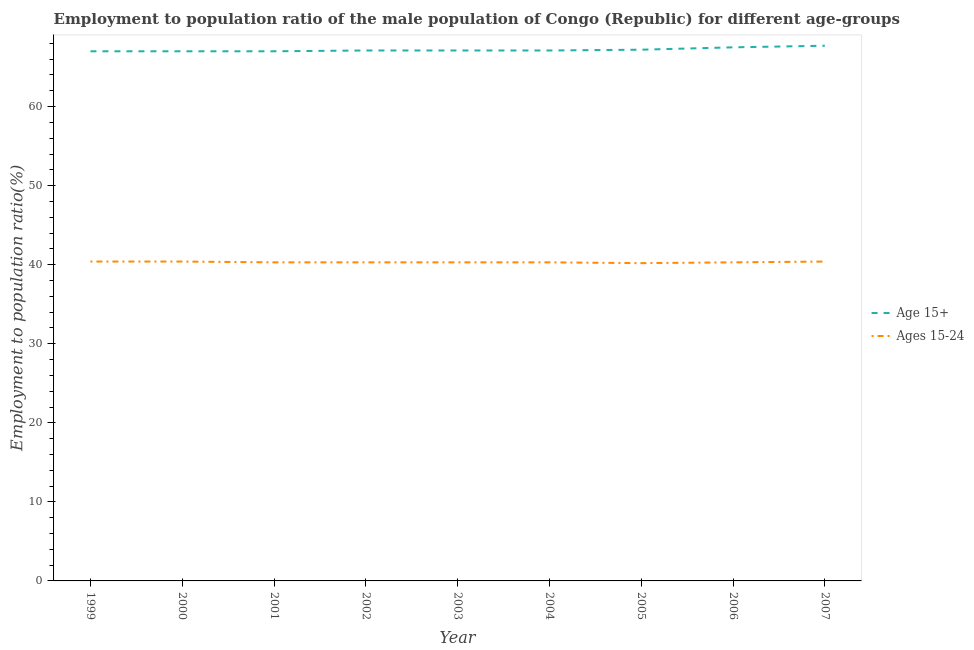How many different coloured lines are there?
Keep it short and to the point. 2. Is the number of lines equal to the number of legend labels?
Give a very brief answer. Yes. What is the employment to population ratio(age 15+) in 2004?
Give a very brief answer. 67.1. Across all years, what is the maximum employment to population ratio(age 15+)?
Offer a very short reply. 67.7. Across all years, what is the minimum employment to population ratio(age 15+)?
Your answer should be compact. 67. What is the total employment to population ratio(age 15+) in the graph?
Your answer should be very brief. 604.7. What is the difference between the employment to population ratio(age 15+) in 1999 and that in 2007?
Ensure brevity in your answer.  -0.7. What is the difference between the employment to population ratio(age 15-24) in 2001 and the employment to population ratio(age 15+) in 2007?
Make the answer very short. -27.4. What is the average employment to population ratio(age 15-24) per year?
Offer a terse response. 40.32. In the year 2004, what is the difference between the employment to population ratio(age 15+) and employment to population ratio(age 15-24)?
Ensure brevity in your answer.  26.8. What is the ratio of the employment to population ratio(age 15-24) in 2001 to that in 2005?
Your answer should be compact. 1. What is the difference between the highest and the lowest employment to population ratio(age 15-24)?
Provide a succinct answer. 0.2. In how many years, is the employment to population ratio(age 15+) greater than the average employment to population ratio(age 15+) taken over all years?
Give a very brief answer. 3. Are the values on the major ticks of Y-axis written in scientific E-notation?
Your answer should be very brief. No. Does the graph contain grids?
Provide a short and direct response. No. Where does the legend appear in the graph?
Offer a very short reply. Center right. How many legend labels are there?
Offer a very short reply. 2. What is the title of the graph?
Your response must be concise. Employment to population ratio of the male population of Congo (Republic) for different age-groups. Does "Personal remittances" appear as one of the legend labels in the graph?
Offer a terse response. No. What is the label or title of the Y-axis?
Ensure brevity in your answer.  Employment to population ratio(%). What is the Employment to population ratio(%) of Ages 15-24 in 1999?
Provide a succinct answer. 40.4. What is the Employment to population ratio(%) in Ages 15-24 in 2000?
Your answer should be very brief. 40.4. What is the Employment to population ratio(%) in Age 15+ in 2001?
Keep it short and to the point. 67. What is the Employment to population ratio(%) of Ages 15-24 in 2001?
Your answer should be very brief. 40.3. What is the Employment to population ratio(%) of Age 15+ in 2002?
Keep it short and to the point. 67.1. What is the Employment to population ratio(%) of Ages 15-24 in 2002?
Provide a short and direct response. 40.3. What is the Employment to population ratio(%) of Age 15+ in 2003?
Your answer should be compact. 67.1. What is the Employment to population ratio(%) of Ages 15-24 in 2003?
Ensure brevity in your answer.  40.3. What is the Employment to population ratio(%) in Age 15+ in 2004?
Offer a terse response. 67.1. What is the Employment to population ratio(%) in Ages 15-24 in 2004?
Offer a very short reply. 40.3. What is the Employment to population ratio(%) in Age 15+ in 2005?
Provide a short and direct response. 67.2. What is the Employment to population ratio(%) of Ages 15-24 in 2005?
Give a very brief answer. 40.2. What is the Employment to population ratio(%) of Age 15+ in 2006?
Offer a terse response. 67.5. What is the Employment to population ratio(%) in Ages 15-24 in 2006?
Keep it short and to the point. 40.3. What is the Employment to population ratio(%) of Age 15+ in 2007?
Your answer should be very brief. 67.7. What is the Employment to population ratio(%) of Ages 15-24 in 2007?
Ensure brevity in your answer.  40.4. Across all years, what is the maximum Employment to population ratio(%) in Age 15+?
Keep it short and to the point. 67.7. Across all years, what is the maximum Employment to population ratio(%) in Ages 15-24?
Give a very brief answer. 40.4. Across all years, what is the minimum Employment to population ratio(%) in Ages 15-24?
Your answer should be compact. 40.2. What is the total Employment to population ratio(%) of Age 15+ in the graph?
Give a very brief answer. 604.7. What is the total Employment to population ratio(%) of Ages 15-24 in the graph?
Ensure brevity in your answer.  362.9. What is the difference between the Employment to population ratio(%) of Age 15+ in 1999 and that in 2000?
Offer a very short reply. 0. What is the difference between the Employment to population ratio(%) in Ages 15-24 in 1999 and that in 2001?
Make the answer very short. 0.1. What is the difference between the Employment to population ratio(%) of Age 15+ in 1999 and that in 2003?
Keep it short and to the point. -0.1. What is the difference between the Employment to population ratio(%) in Age 15+ in 1999 and that in 2004?
Your answer should be very brief. -0.1. What is the difference between the Employment to population ratio(%) in Ages 15-24 in 1999 and that in 2004?
Provide a succinct answer. 0.1. What is the difference between the Employment to population ratio(%) of Age 15+ in 1999 and that in 2005?
Your answer should be compact. -0.2. What is the difference between the Employment to population ratio(%) in Age 15+ in 1999 and that in 2007?
Offer a very short reply. -0.7. What is the difference between the Employment to population ratio(%) in Age 15+ in 2000 and that in 2002?
Ensure brevity in your answer.  -0.1. What is the difference between the Employment to population ratio(%) of Ages 15-24 in 2000 and that in 2002?
Make the answer very short. 0.1. What is the difference between the Employment to population ratio(%) of Age 15+ in 2000 and that in 2003?
Give a very brief answer. -0.1. What is the difference between the Employment to population ratio(%) of Ages 15-24 in 2000 and that in 2003?
Ensure brevity in your answer.  0.1. What is the difference between the Employment to population ratio(%) in Ages 15-24 in 2000 and that in 2004?
Offer a terse response. 0.1. What is the difference between the Employment to population ratio(%) in Age 15+ in 2000 and that in 2006?
Offer a very short reply. -0.5. What is the difference between the Employment to population ratio(%) in Ages 15-24 in 2001 and that in 2002?
Offer a terse response. 0. What is the difference between the Employment to population ratio(%) of Age 15+ in 2001 and that in 2003?
Your answer should be compact. -0.1. What is the difference between the Employment to population ratio(%) of Ages 15-24 in 2001 and that in 2003?
Offer a very short reply. 0. What is the difference between the Employment to population ratio(%) of Age 15+ in 2001 and that in 2004?
Offer a very short reply. -0.1. What is the difference between the Employment to population ratio(%) in Age 15+ in 2001 and that in 2005?
Offer a very short reply. -0.2. What is the difference between the Employment to population ratio(%) of Age 15+ in 2001 and that in 2006?
Keep it short and to the point. -0.5. What is the difference between the Employment to population ratio(%) in Age 15+ in 2001 and that in 2007?
Ensure brevity in your answer.  -0.7. What is the difference between the Employment to population ratio(%) in Age 15+ in 2002 and that in 2003?
Keep it short and to the point. 0. What is the difference between the Employment to population ratio(%) in Age 15+ in 2002 and that in 2005?
Your response must be concise. -0.1. What is the difference between the Employment to population ratio(%) of Ages 15-24 in 2002 and that in 2005?
Offer a terse response. 0.1. What is the difference between the Employment to population ratio(%) of Ages 15-24 in 2003 and that in 2004?
Give a very brief answer. 0. What is the difference between the Employment to population ratio(%) in Age 15+ in 2003 and that in 2005?
Provide a short and direct response. -0.1. What is the difference between the Employment to population ratio(%) in Age 15+ in 2004 and that in 2005?
Ensure brevity in your answer.  -0.1. What is the difference between the Employment to population ratio(%) of Ages 15-24 in 2004 and that in 2005?
Your answer should be very brief. 0.1. What is the difference between the Employment to population ratio(%) of Age 15+ in 2004 and that in 2006?
Keep it short and to the point. -0.4. What is the difference between the Employment to population ratio(%) of Ages 15-24 in 2004 and that in 2007?
Make the answer very short. -0.1. What is the difference between the Employment to population ratio(%) in Ages 15-24 in 2006 and that in 2007?
Give a very brief answer. -0.1. What is the difference between the Employment to population ratio(%) in Age 15+ in 1999 and the Employment to population ratio(%) in Ages 15-24 in 2000?
Your answer should be compact. 26.6. What is the difference between the Employment to population ratio(%) of Age 15+ in 1999 and the Employment to population ratio(%) of Ages 15-24 in 2001?
Your answer should be very brief. 26.7. What is the difference between the Employment to population ratio(%) of Age 15+ in 1999 and the Employment to population ratio(%) of Ages 15-24 in 2002?
Provide a short and direct response. 26.7. What is the difference between the Employment to population ratio(%) in Age 15+ in 1999 and the Employment to population ratio(%) in Ages 15-24 in 2003?
Your response must be concise. 26.7. What is the difference between the Employment to population ratio(%) in Age 15+ in 1999 and the Employment to population ratio(%) in Ages 15-24 in 2004?
Offer a very short reply. 26.7. What is the difference between the Employment to population ratio(%) in Age 15+ in 1999 and the Employment to population ratio(%) in Ages 15-24 in 2005?
Your answer should be compact. 26.8. What is the difference between the Employment to population ratio(%) of Age 15+ in 1999 and the Employment to population ratio(%) of Ages 15-24 in 2006?
Ensure brevity in your answer.  26.7. What is the difference between the Employment to population ratio(%) of Age 15+ in 1999 and the Employment to population ratio(%) of Ages 15-24 in 2007?
Your response must be concise. 26.6. What is the difference between the Employment to population ratio(%) of Age 15+ in 2000 and the Employment to population ratio(%) of Ages 15-24 in 2001?
Make the answer very short. 26.7. What is the difference between the Employment to population ratio(%) of Age 15+ in 2000 and the Employment to population ratio(%) of Ages 15-24 in 2002?
Keep it short and to the point. 26.7. What is the difference between the Employment to population ratio(%) in Age 15+ in 2000 and the Employment to population ratio(%) in Ages 15-24 in 2003?
Provide a short and direct response. 26.7. What is the difference between the Employment to population ratio(%) of Age 15+ in 2000 and the Employment to population ratio(%) of Ages 15-24 in 2004?
Offer a terse response. 26.7. What is the difference between the Employment to population ratio(%) in Age 15+ in 2000 and the Employment to population ratio(%) in Ages 15-24 in 2005?
Offer a terse response. 26.8. What is the difference between the Employment to population ratio(%) in Age 15+ in 2000 and the Employment to population ratio(%) in Ages 15-24 in 2006?
Your answer should be compact. 26.7. What is the difference between the Employment to population ratio(%) in Age 15+ in 2000 and the Employment to population ratio(%) in Ages 15-24 in 2007?
Your answer should be very brief. 26.6. What is the difference between the Employment to population ratio(%) of Age 15+ in 2001 and the Employment to population ratio(%) of Ages 15-24 in 2002?
Offer a very short reply. 26.7. What is the difference between the Employment to population ratio(%) of Age 15+ in 2001 and the Employment to population ratio(%) of Ages 15-24 in 2003?
Give a very brief answer. 26.7. What is the difference between the Employment to population ratio(%) of Age 15+ in 2001 and the Employment to population ratio(%) of Ages 15-24 in 2004?
Provide a short and direct response. 26.7. What is the difference between the Employment to population ratio(%) of Age 15+ in 2001 and the Employment to population ratio(%) of Ages 15-24 in 2005?
Provide a short and direct response. 26.8. What is the difference between the Employment to population ratio(%) in Age 15+ in 2001 and the Employment to population ratio(%) in Ages 15-24 in 2006?
Ensure brevity in your answer.  26.7. What is the difference between the Employment to population ratio(%) of Age 15+ in 2001 and the Employment to population ratio(%) of Ages 15-24 in 2007?
Keep it short and to the point. 26.6. What is the difference between the Employment to population ratio(%) in Age 15+ in 2002 and the Employment to population ratio(%) in Ages 15-24 in 2003?
Your answer should be very brief. 26.8. What is the difference between the Employment to population ratio(%) in Age 15+ in 2002 and the Employment to population ratio(%) in Ages 15-24 in 2004?
Offer a very short reply. 26.8. What is the difference between the Employment to population ratio(%) of Age 15+ in 2002 and the Employment to population ratio(%) of Ages 15-24 in 2005?
Ensure brevity in your answer.  26.9. What is the difference between the Employment to population ratio(%) in Age 15+ in 2002 and the Employment to population ratio(%) in Ages 15-24 in 2006?
Offer a very short reply. 26.8. What is the difference between the Employment to population ratio(%) in Age 15+ in 2002 and the Employment to population ratio(%) in Ages 15-24 in 2007?
Your response must be concise. 26.7. What is the difference between the Employment to population ratio(%) of Age 15+ in 2003 and the Employment to population ratio(%) of Ages 15-24 in 2004?
Offer a very short reply. 26.8. What is the difference between the Employment to population ratio(%) of Age 15+ in 2003 and the Employment to population ratio(%) of Ages 15-24 in 2005?
Give a very brief answer. 26.9. What is the difference between the Employment to population ratio(%) in Age 15+ in 2003 and the Employment to population ratio(%) in Ages 15-24 in 2006?
Ensure brevity in your answer.  26.8. What is the difference between the Employment to population ratio(%) of Age 15+ in 2003 and the Employment to population ratio(%) of Ages 15-24 in 2007?
Keep it short and to the point. 26.7. What is the difference between the Employment to population ratio(%) in Age 15+ in 2004 and the Employment to population ratio(%) in Ages 15-24 in 2005?
Ensure brevity in your answer.  26.9. What is the difference between the Employment to population ratio(%) of Age 15+ in 2004 and the Employment to population ratio(%) of Ages 15-24 in 2006?
Make the answer very short. 26.8. What is the difference between the Employment to population ratio(%) in Age 15+ in 2004 and the Employment to population ratio(%) in Ages 15-24 in 2007?
Your response must be concise. 26.7. What is the difference between the Employment to population ratio(%) of Age 15+ in 2005 and the Employment to population ratio(%) of Ages 15-24 in 2006?
Give a very brief answer. 26.9. What is the difference between the Employment to population ratio(%) of Age 15+ in 2005 and the Employment to population ratio(%) of Ages 15-24 in 2007?
Offer a terse response. 26.8. What is the difference between the Employment to population ratio(%) in Age 15+ in 2006 and the Employment to population ratio(%) in Ages 15-24 in 2007?
Offer a terse response. 27.1. What is the average Employment to population ratio(%) of Age 15+ per year?
Give a very brief answer. 67.19. What is the average Employment to population ratio(%) in Ages 15-24 per year?
Make the answer very short. 40.32. In the year 1999, what is the difference between the Employment to population ratio(%) of Age 15+ and Employment to population ratio(%) of Ages 15-24?
Keep it short and to the point. 26.6. In the year 2000, what is the difference between the Employment to population ratio(%) of Age 15+ and Employment to population ratio(%) of Ages 15-24?
Provide a succinct answer. 26.6. In the year 2001, what is the difference between the Employment to population ratio(%) in Age 15+ and Employment to population ratio(%) in Ages 15-24?
Keep it short and to the point. 26.7. In the year 2002, what is the difference between the Employment to population ratio(%) of Age 15+ and Employment to population ratio(%) of Ages 15-24?
Provide a succinct answer. 26.8. In the year 2003, what is the difference between the Employment to population ratio(%) in Age 15+ and Employment to population ratio(%) in Ages 15-24?
Your answer should be very brief. 26.8. In the year 2004, what is the difference between the Employment to population ratio(%) in Age 15+ and Employment to population ratio(%) in Ages 15-24?
Ensure brevity in your answer.  26.8. In the year 2005, what is the difference between the Employment to population ratio(%) in Age 15+ and Employment to population ratio(%) in Ages 15-24?
Your answer should be compact. 27. In the year 2006, what is the difference between the Employment to population ratio(%) in Age 15+ and Employment to population ratio(%) in Ages 15-24?
Keep it short and to the point. 27.2. In the year 2007, what is the difference between the Employment to population ratio(%) in Age 15+ and Employment to population ratio(%) in Ages 15-24?
Ensure brevity in your answer.  27.3. What is the ratio of the Employment to population ratio(%) in Age 15+ in 1999 to that in 2001?
Ensure brevity in your answer.  1. What is the ratio of the Employment to population ratio(%) in Ages 15-24 in 1999 to that in 2001?
Your answer should be compact. 1. What is the ratio of the Employment to population ratio(%) in Ages 15-24 in 1999 to that in 2002?
Provide a short and direct response. 1. What is the ratio of the Employment to population ratio(%) of Age 15+ in 1999 to that in 2004?
Offer a terse response. 1. What is the ratio of the Employment to population ratio(%) in Ages 15-24 in 1999 to that in 2004?
Offer a terse response. 1. What is the ratio of the Employment to population ratio(%) of Age 15+ in 1999 to that in 2005?
Ensure brevity in your answer.  1. What is the ratio of the Employment to population ratio(%) in Age 15+ in 1999 to that in 2007?
Ensure brevity in your answer.  0.99. What is the ratio of the Employment to population ratio(%) of Age 15+ in 2000 to that in 2001?
Provide a succinct answer. 1. What is the ratio of the Employment to population ratio(%) in Ages 15-24 in 2000 to that in 2001?
Provide a short and direct response. 1. What is the ratio of the Employment to population ratio(%) of Ages 15-24 in 2000 to that in 2002?
Your answer should be compact. 1. What is the ratio of the Employment to population ratio(%) in Age 15+ in 2000 to that in 2003?
Offer a very short reply. 1. What is the ratio of the Employment to population ratio(%) in Ages 15-24 in 2000 to that in 2003?
Offer a very short reply. 1. What is the ratio of the Employment to population ratio(%) in Age 15+ in 2000 to that in 2005?
Offer a terse response. 1. What is the ratio of the Employment to population ratio(%) of Ages 15-24 in 2000 to that in 2006?
Ensure brevity in your answer.  1. What is the ratio of the Employment to population ratio(%) in Ages 15-24 in 2001 to that in 2003?
Provide a succinct answer. 1. What is the ratio of the Employment to population ratio(%) in Ages 15-24 in 2001 to that in 2004?
Provide a short and direct response. 1. What is the ratio of the Employment to population ratio(%) in Ages 15-24 in 2001 to that in 2005?
Offer a terse response. 1. What is the ratio of the Employment to population ratio(%) in Age 15+ in 2001 to that in 2006?
Your answer should be compact. 0.99. What is the ratio of the Employment to population ratio(%) in Age 15+ in 2001 to that in 2007?
Offer a terse response. 0.99. What is the ratio of the Employment to population ratio(%) of Ages 15-24 in 2001 to that in 2007?
Make the answer very short. 1. What is the ratio of the Employment to population ratio(%) of Age 15+ in 2002 to that in 2003?
Make the answer very short. 1. What is the ratio of the Employment to population ratio(%) of Ages 15-24 in 2002 to that in 2003?
Offer a terse response. 1. What is the ratio of the Employment to population ratio(%) of Age 15+ in 2002 to that in 2004?
Keep it short and to the point. 1. What is the ratio of the Employment to population ratio(%) in Ages 15-24 in 2002 to that in 2004?
Ensure brevity in your answer.  1. What is the ratio of the Employment to population ratio(%) in Age 15+ in 2002 to that in 2007?
Your answer should be very brief. 0.99. What is the ratio of the Employment to population ratio(%) in Ages 15-24 in 2002 to that in 2007?
Provide a short and direct response. 1. What is the ratio of the Employment to population ratio(%) of Ages 15-24 in 2003 to that in 2005?
Keep it short and to the point. 1. What is the ratio of the Employment to population ratio(%) in Age 15+ in 2003 to that in 2006?
Provide a short and direct response. 0.99. What is the ratio of the Employment to population ratio(%) of Age 15+ in 2003 to that in 2007?
Your answer should be very brief. 0.99. What is the ratio of the Employment to population ratio(%) in Ages 15-24 in 2004 to that in 2007?
Give a very brief answer. 1. What is the ratio of the Employment to population ratio(%) in Age 15+ in 2005 to that in 2007?
Offer a terse response. 0.99. What is the ratio of the Employment to population ratio(%) in Ages 15-24 in 2006 to that in 2007?
Your answer should be very brief. 1. What is the difference between the highest and the second highest Employment to population ratio(%) in Ages 15-24?
Your response must be concise. 0. 